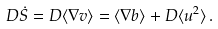Convert formula to latex. <formula><loc_0><loc_0><loc_500><loc_500>D \dot { S } = D \langle \nabla v \rangle = \langle \nabla b \rangle + D \langle u ^ { 2 } \rangle \, .</formula> 